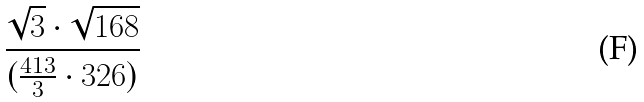<formula> <loc_0><loc_0><loc_500><loc_500>\frac { \sqrt { 3 } \cdot \sqrt { 1 6 8 } } { ( \frac { 4 1 3 } { 3 } \cdot 3 2 6 ) }</formula> 